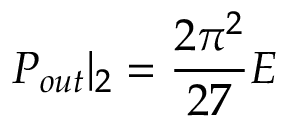Convert formula to latex. <formula><loc_0><loc_0><loc_500><loc_500>P _ { o u t } | _ { 2 } = \frac { 2 \pi ^ { 2 } } { 2 7 } E</formula> 